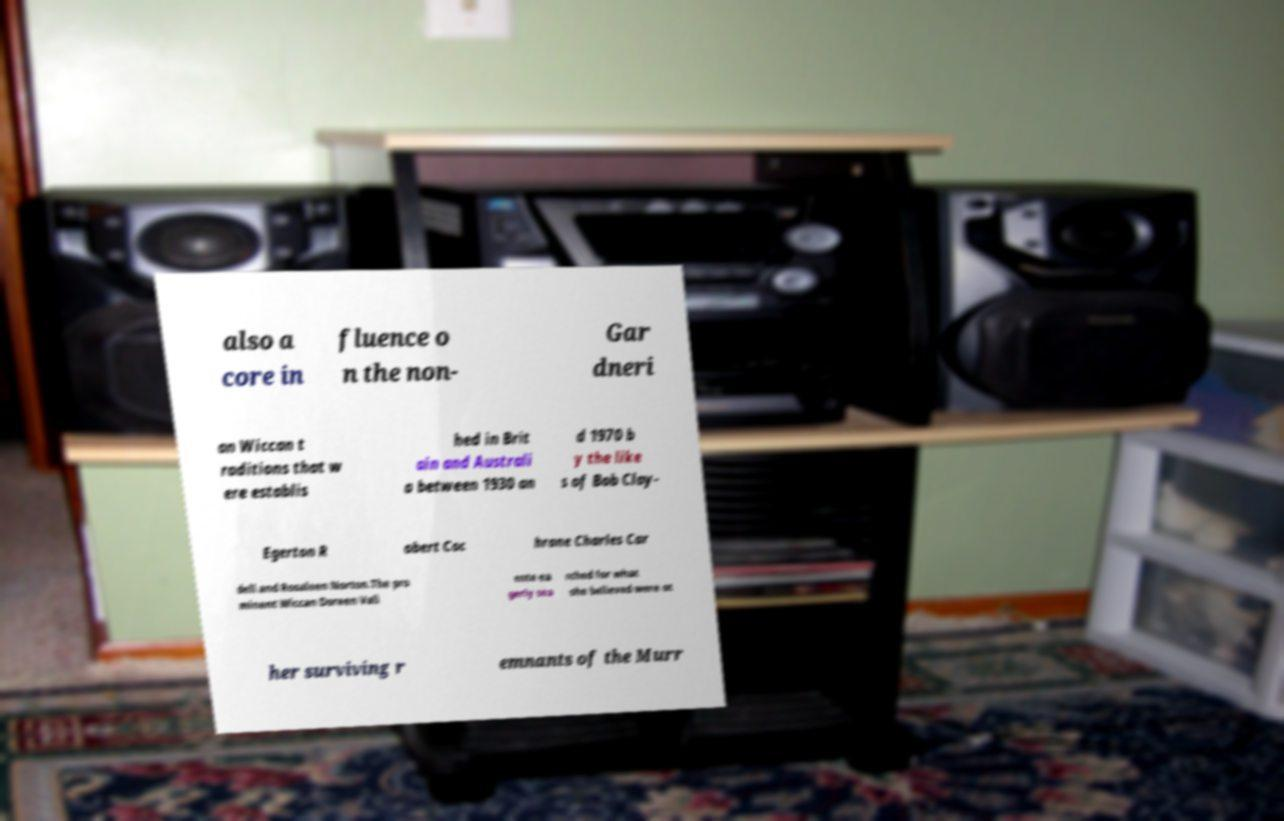Could you extract and type out the text from this image? also a core in fluence o n the non- Gar dneri an Wiccan t raditions that w ere establis hed in Brit ain and Australi a between 1930 an d 1970 b y the like s of Bob Clay- Egerton R obert Coc hrane Charles Car dell and Rosaleen Norton.The pro minent Wiccan Doreen Vali ente ea gerly sea rched for what she believed were ot her surviving r emnants of the Murr 